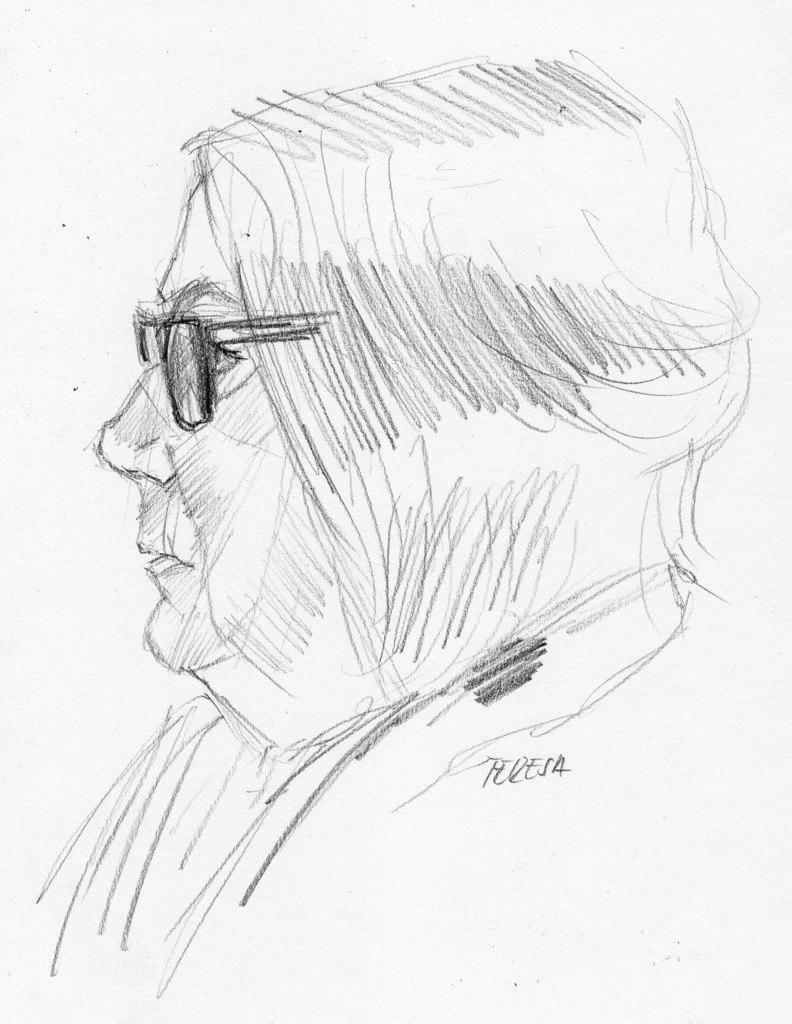Can you describe this image briefly? In the image we can see a drawing. 